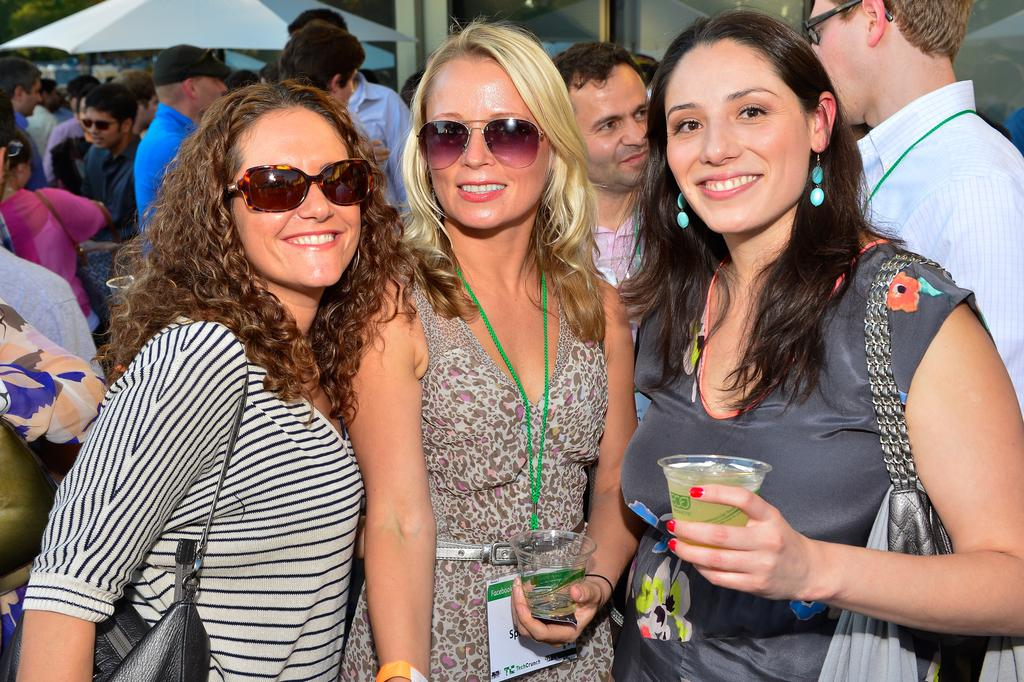How many people are standing in the image? There are three people standing in the image. What are the women holding in the image? Two women are holding cups in the image. What is the facial expression of the women? The women are smiling. Can you describe the people behind the main subjects? There are groups of people behind the main subjects. What is one specific object visible in the image? There is an umbrella visible in the image. What other unspecified objects can be seen in the background? There are other unspecified objects in the background. What type of seed is being planted by the women in the image? There is no seed or planting activity depicted in the image; the women are holding cups and smiling. 